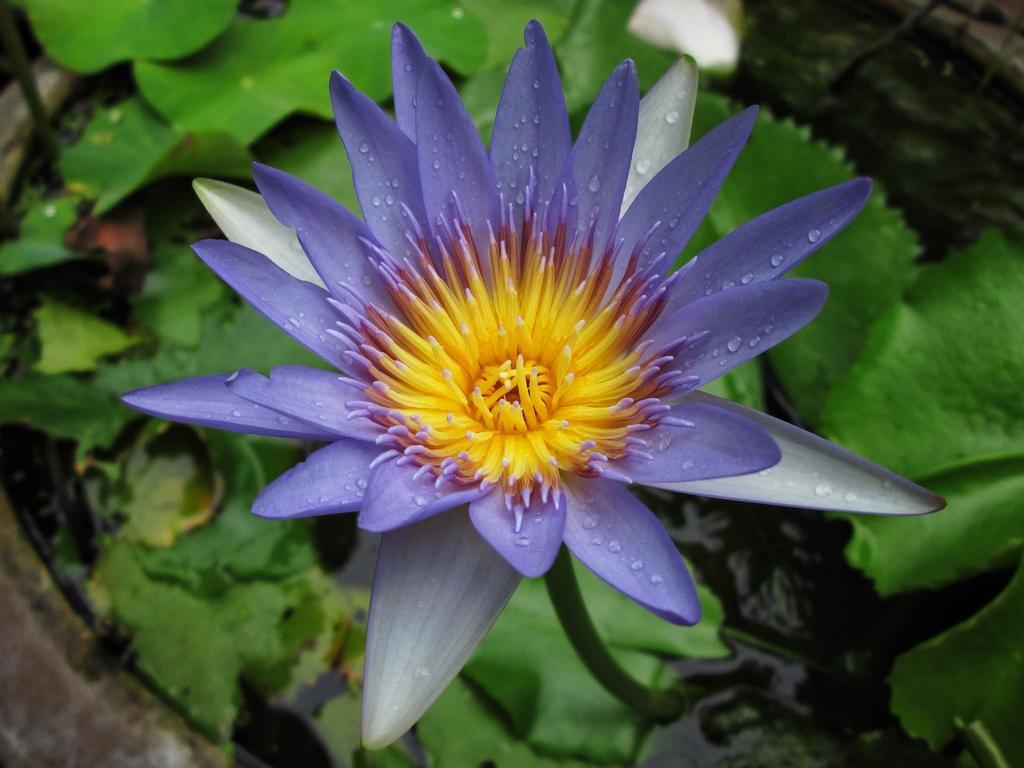Please provide a concise description of this image. In this image we can see violet and yellow color flower with green leaves and water in the background. 